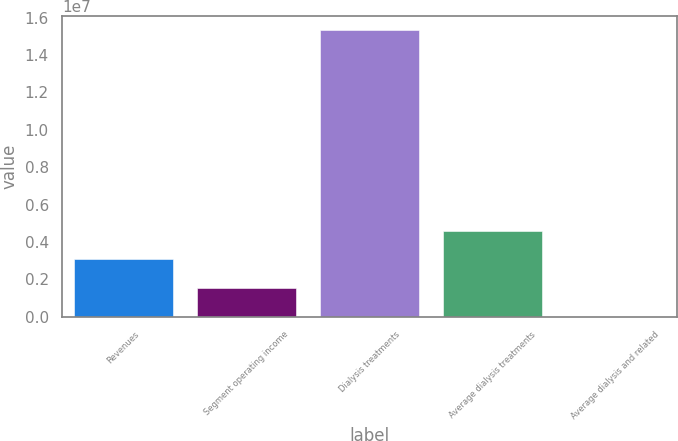<chart> <loc_0><loc_0><loc_500><loc_500><bar_chart><fcel>Revenues<fcel>Segment operating income<fcel>Dialysis treatments<fcel>Average dialysis treatments<fcel>Average dialysis and related<nl><fcel>3.06407e+06<fcel>1.5322e+06<fcel>1.5319e+07<fcel>4.59593e+06<fcel>334<nl></chart> 